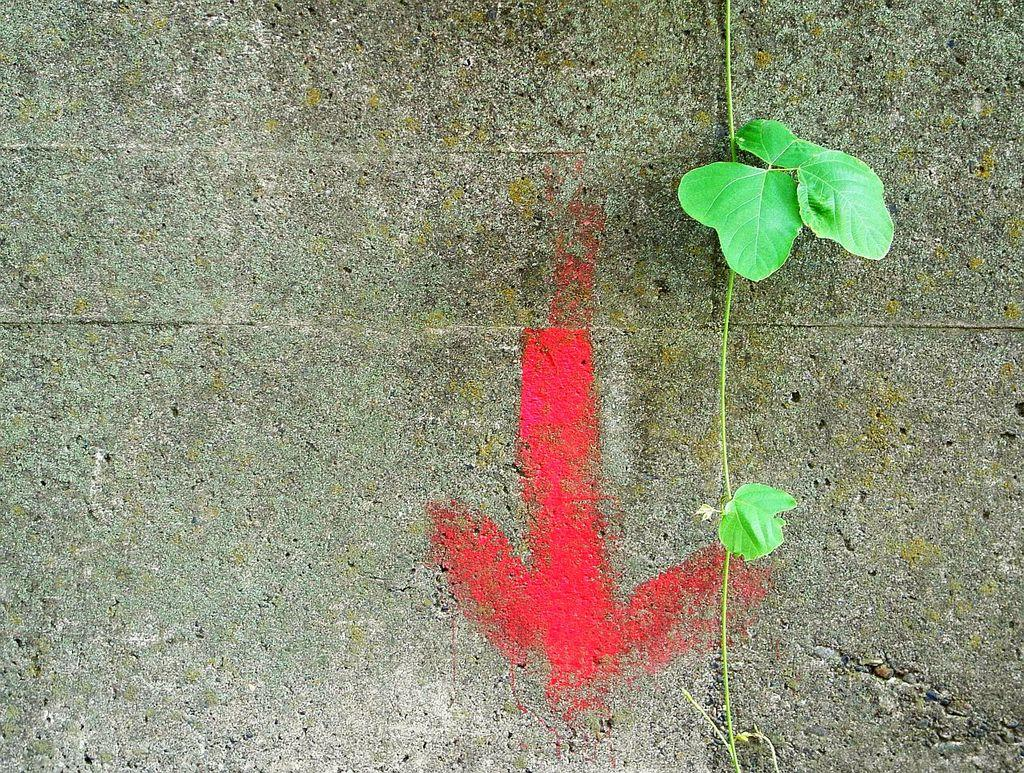What type of vegetation is present in the image? There are leaves in the image. Can you describe the structure that connects the leaves? There is a stem in the image. What is the color of the symbol on the wall in the image? The symbol on the wall in the image is red. What type of metal is used to make the flavor of the leaves in the image? There is no mention of metal or flavor in the image; it features leaves and a stem. 